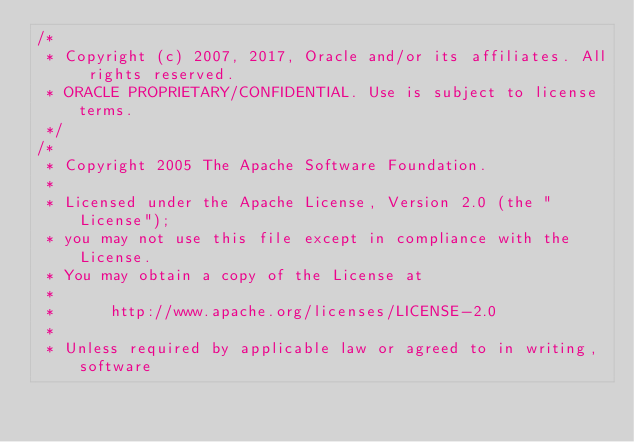<code> <loc_0><loc_0><loc_500><loc_500><_Java_>/*
 * Copyright (c) 2007, 2017, Oracle and/or its affiliates. All rights reserved.
 * ORACLE PROPRIETARY/CONFIDENTIAL. Use is subject to license terms.
 */
/*
 * Copyright 2005 The Apache Software Foundation.
 *
 * Licensed under the Apache License, Version 2.0 (the "License");
 * you may not use this file except in compliance with the License.
 * You may obtain a copy of the License at
 *
 *      http://www.apache.org/licenses/LICENSE-2.0
 *
 * Unless required by applicable law or agreed to in writing, software</code> 